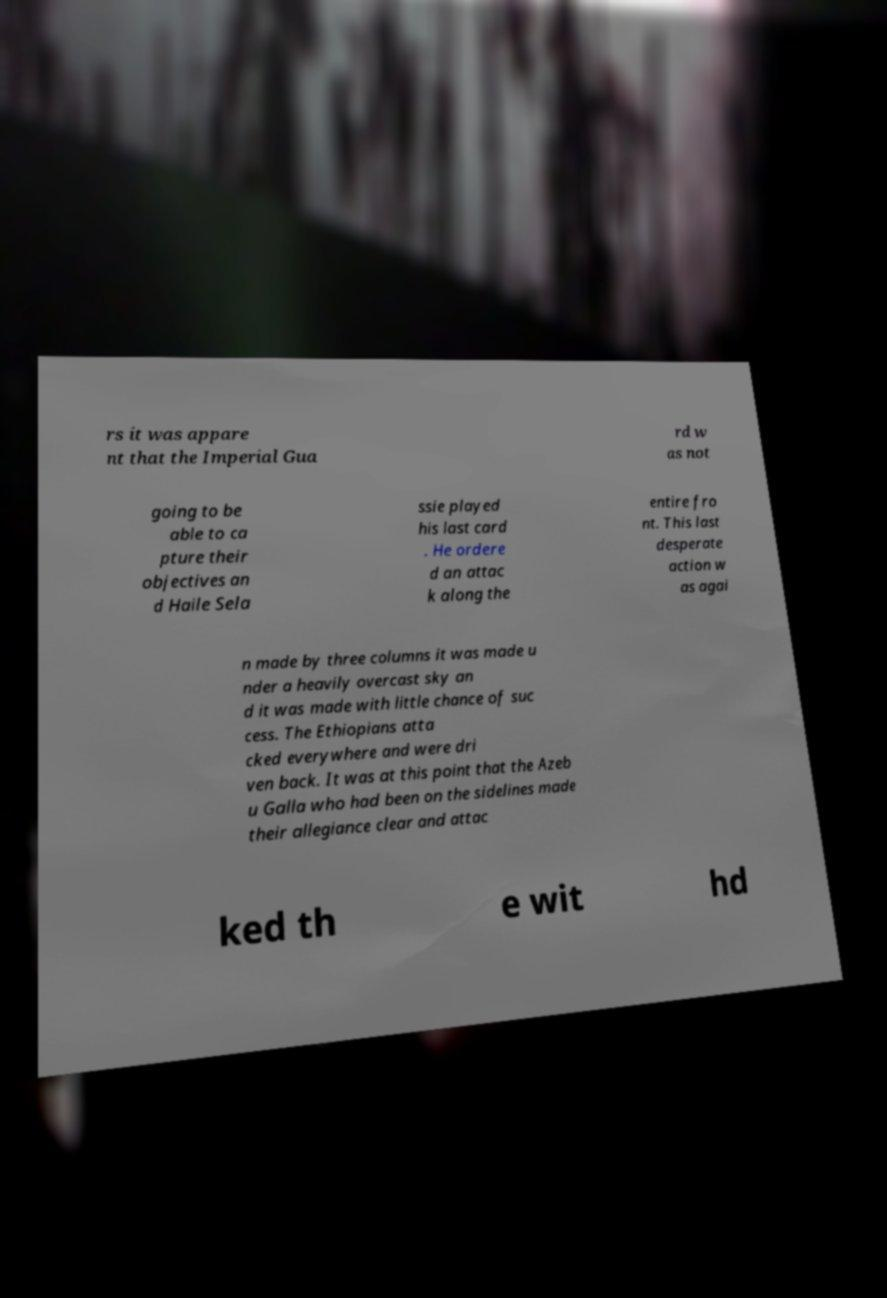Could you extract and type out the text from this image? rs it was appare nt that the Imperial Gua rd w as not going to be able to ca pture their objectives an d Haile Sela ssie played his last card . He ordere d an attac k along the entire fro nt. This last desperate action w as agai n made by three columns it was made u nder a heavily overcast sky an d it was made with little chance of suc cess. The Ethiopians atta cked everywhere and were dri ven back. It was at this point that the Azeb u Galla who had been on the sidelines made their allegiance clear and attac ked th e wit hd 